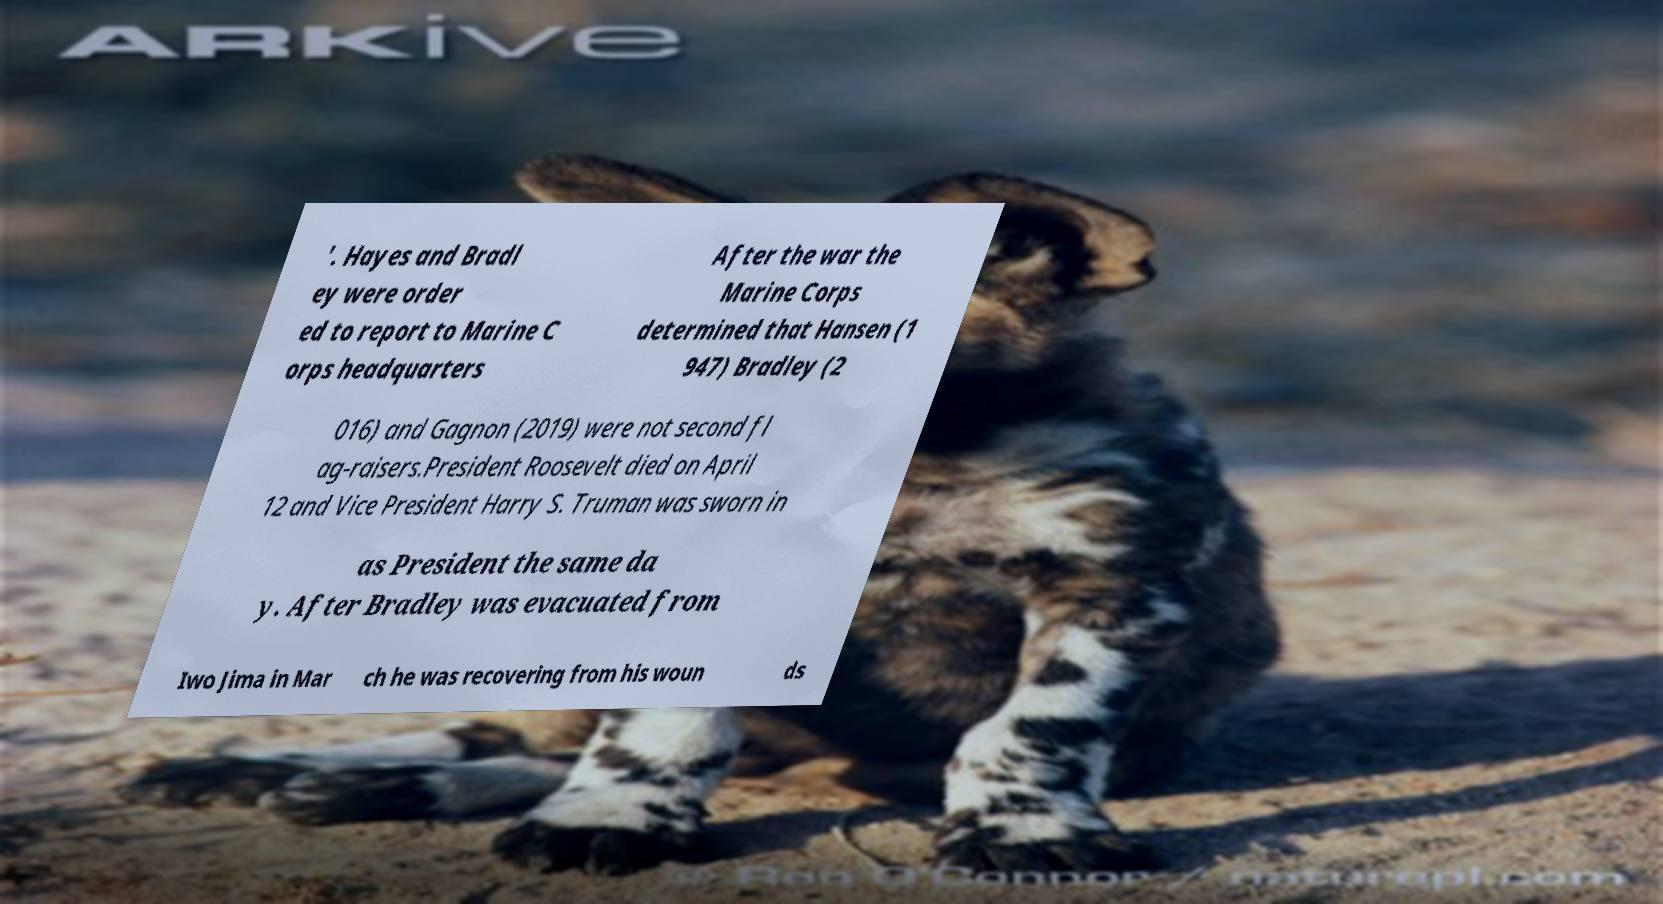Could you extract and type out the text from this image? '. Hayes and Bradl ey were order ed to report to Marine C orps headquarters After the war the Marine Corps determined that Hansen (1 947) Bradley (2 016) and Gagnon (2019) were not second fl ag-raisers.President Roosevelt died on April 12 and Vice President Harry S. Truman was sworn in as President the same da y. After Bradley was evacuated from Iwo Jima in Mar ch he was recovering from his woun ds 